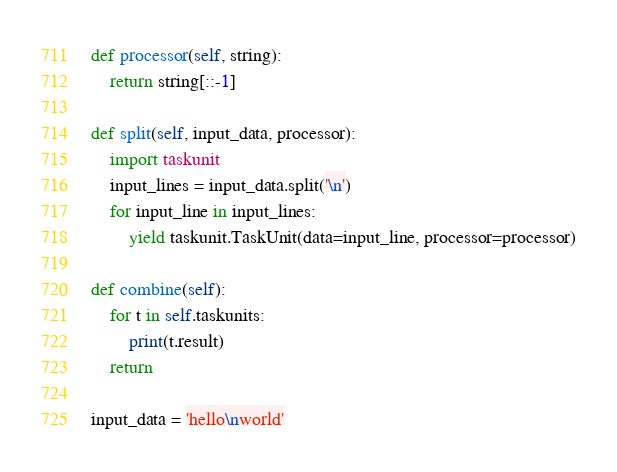Convert code to text. <code><loc_0><loc_0><loc_500><loc_500><_Python_>def processor(self, string):
    return string[::-1]

def split(self, input_data, processor):
    import taskunit
    input_lines = input_data.split('\n')
    for input_line in input_lines:
        yield taskunit.TaskUnit(data=input_line, processor=processor)

def combine(self):
    for t in self.taskunits:
        print(t.result)
    return

input_data = 'hello\nworld'
</code> 